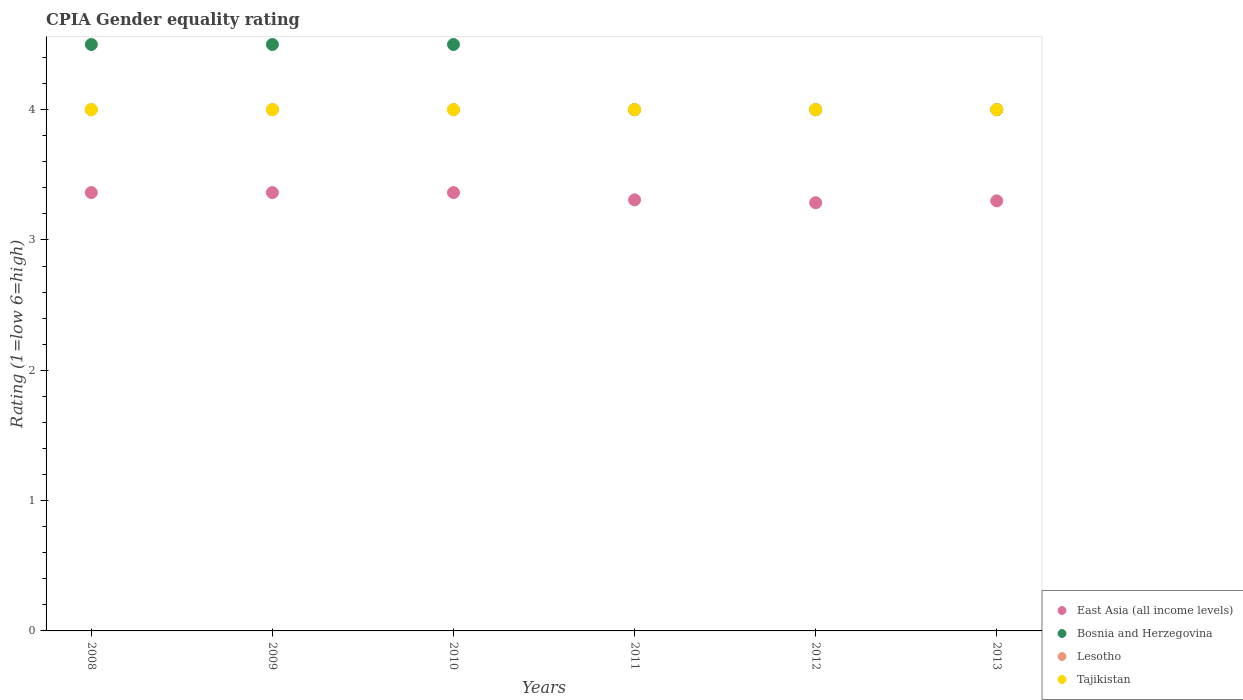How many different coloured dotlines are there?
Your response must be concise. 4. What is the CPIA rating in East Asia (all income levels) in 2010?
Offer a terse response. 3.36. Across all years, what is the maximum CPIA rating in Lesotho?
Make the answer very short. 4. Across all years, what is the minimum CPIA rating in Lesotho?
Ensure brevity in your answer.  4. What is the total CPIA rating in East Asia (all income levels) in the graph?
Give a very brief answer. 19.98. What is the difference between the CPIA rating in East Asia (all income levels) in 2009 and that in 2011?
Make the answer very short. 0.06. What is the average CPIA rating in Bosnia and Herzegovina per year?
Ensure brevity in your answer.  4.25. In the year 2008, what is the difference between the CPIA rating in East Asia (all income levels) and CPIA rating in Lesotho?
Give a very brief answer. -0.64. In how many years, is the CPIA rating in East Asia (all income levels) greater than 2.8?
Make the answer very short. 6. What is the difference between the highest and the second highest CPIA rating in Lesotho?
Your response must be concise. 0. In how many years, is the CPIA rating in East Asia (all income levels) greater than the average CPIA rating in East Asia (all income levels) taken over all years?
Ensure brevity in your answer.  3. Is the sum of the CPIA rating in Lesotho in 2009 and 2010 greater than the maximum CPIA rating in Bosnia and Herzegovina across all years?
Your answer should be very brief. Yes. Is it the case that in every year, the sum of the CPIA rating in East Asia (all income levels) and CPIA rating in Lesotho  is greater than the sum of CPIA rating in Bosnia and Herzegovina and CPIA rating in Tajikistan?
Your response must be concise. No. Is it the case that in every year, the sum of the CPIA rating in East Asia (all income levels) and CPIA rating in Lesotho  is greater than the CPIA rating in Tajikistan?
Make the answer very short. Yes. Is the CPIA rating in Lesotho strictly greater than the CPIA rating in Bosnia and Herzegovina over the years?
Make the answer very short. No. How many years are there in the graph?
Offer a very short reply. 6. What is the difference between two consecutive major ticks on the Y-axis?
Make the answer very short. 1. Are the values on the major ticks of Y-axis written in scientific E-notation?
Offer a very short reply. No. Does the graph contain any zero values?
Keep it short and to the point. No. Does the graph contain grids?
Provide a succinct answer. No. Where does the legend appear in the graph?
Provide a short and direct response. Bottom right. What is the title of the graph?
Provide a short and direct response. CPIA Gender equality rating. What is the label or title of the X-axis?
Give a very brief answer. Years. What is the Rating (1=low 6=high) of East Asia (all income levels) in 2008?
Your answer should be compact. 3.36. What is the Rating (1=low 6=high) of Lesotho in 2008?
Keep it short and to the point. 4. What is the Rating (1=low 6=high) of Tajikistan in 2008?
Your answer should be very brief. 4. What is the Rating (1=low 6=high) in East Asia (all income levels) in 2009?
Keep it short and to the point. 3.36. What is the Rating (1=low 6=high) in Lesotho in 2009?
Offer a very short reply. 4. What is the Rating (1=low 6=high) in East Asia (all income levels) in 2010?
Offer a terse response. 3.36. What is the Rating (1=low 6=high) of Lesotho in 2010?
Give a very brief answer. 4. What is the Rating (1=low 6=high) in East Asia (all income levels) in 2011?
Offer a very short reply. 3.31. What is the Rating (1=low 6=high) in Lesotho in 2011?
Offer a terse response. 4. What is the Rating (1=low 6=high) in East Asia (all income levels) in 2012?
Your response must be concise. 3.29. What is the Rating (1=low 6=high) in Tajikistan in 2012?
Give a very brief answer. 4. What is the Rating (1=low 6=high) of East Asia (all income levels) in 2013?
Ensure brevity in your answer.  3.3. What is the Rating (1=low 6=high) in Lesotho in 2013?
Your response must be concise. 4. Across all years, what is the maximum Rating (1=low 6=high) of East Asia (all income levels)?
Your response must be concise. 3.36. Across all years, what is the maximum Rating (1=low 6=high) of Tajikistan?
Ensure brevity in your answer.  4. Across all years, what is the minimum Rating (1=low 6=high) of East Asia (all income levels)?
Offer a very short reply. 3.29. Across all years, what is the minimum Rating (1=low 6=high) of Lesotho?
Your answer should be very brief. 4. Across all years, what is the minimum Rating (1=low 6=high) of Tajikistan?
Keep it short and to the point. 4. What is the total Rating (1=low 6=high) of East Asia (all income levels) in the graph?
Provide a succinct answer. 19.98. What is the total Rating (1=low 6=high) in Lesotho in the graph?
Your response must be concise. 24. What is the difference between the Rating (1=low 6=high) in East Asia (all income levels) in 2008 and that in 2009?
Offer a very short reply. 0. What is the difference between the Rating (1=low 6=high) of Lesotho in 2008 and that in 2009?
Give a very brief answer. 0. What is the difference between the Rating (1=low 6=high) of Tajikistan in 2008 and that in 2009?
Your response must be concise. 0. What is the difference between the Rating (1=low 6=high) in Bosnia and Herzegovina in 2008 and that in 2010?
Offer a terse response. 0. What is the difference between the Rating (1=low 6=high) of East Asia (all income levels) in 2008 and that in 2011?
Provide a succinct answer. 0.06. What is the difference between the Rating (1=low 6=high) in East Asia (all income levels) in 2008 and that in 2012?
Your response must be concise. 0.08. What is the difference between the Rating (1=low 6=high) in East Asia (all income levels) in 2008 and that in 2013?
Your answer should be compact. 0.06. What is the difference between the Rating (1=low 6=high) in Bosnia and Herzegovina in 2008 and that in 2013?
Ensure brevity in your answer.  0.5. What is the difference between the Rating (1=low 6=high) of East Asia (all income levels) in 2009 and that in 2010?
Ensure brevity in your answer.  0. What is the difference between the Rating (1=low 6=high) in Tajikistan in 2009 and that in 2010?
Your answer should be very brief. 0. What is the difference between the Rating (1=low 6=high) in East Asia (all income levels) in 2009 and that in 2011?
Your answer should be very brief. 0.06. What is the difference between the Rating (1=low 6=high) in Bosnia and Herzegovina in 2009 and that in 2011?
Provide a succinct answer. 0.5. What is the difference between the Rating (1=low 6=high) in Tajikistan in 2009 and that in 2011?
Your answer should be compact. 0. What is the difference between the Rating (1=low 6=high) in East Asia (all income levels) in 2009 and that in 2012?
Make the answer very short. 0.08. What is the difference between the Rating (1=low 6=high) in Lesotho in 2009 and that in 2012?
Offer a terse response. 0. What is the difference between the Rating (1=low 6=high) in East Asia (all income levels) in 2009 and that in 2013?
Keep it short and to the point. 0.06. What is the difference between the Rating (1=low 6=high) in Bosnia and Herzegovina in 2009 and that in 2013?
Ensure brevity in your answer.  0.5. What is the difference between the Rating (1=low 6=high) in Lesotho in 2009 and that in 2013?
Your answer should be compact. 0. What is the difference between the Rating (1=low 6=high) of East Asia (all income levels) in 2010 and that in 2011?
Your response must be concise. 0.06. What is the difference between the Rating (1=low 6=high) of Lesotho in 2010 and that in 2011?
Offer a terse response. 0. What is the difference between the Rating (1=low 6=high) of Tajikistan in 2010 and that in 2011?
Give a very brief answer. 0. What is the difference between the Rating (1=low 6=high) of East Asia (all income levels) in 2010 and that in 2012?
Keep it short and to the point. 0.08. What is the difference between the Rating (1=low 6=high) of Bosnia and Herzegovina in 2010 and that in 2012?
Your response must be concise. 0.5. What is the difference between the Rating (1=low 6=high) in Tajikistan in 2010 and that in 2012?
Make the answer very short. 0. What is the difference between the Rating (1=low 6=high) in East Asia (all income levels) in 2010 and that in 2013?
Keep it short and to the point. 0.06. What is the difference between the Rating (1=low 6=high) of Bosnia and Herzegovina in 2010 and that in 2013?
Provide a short and direct response. 0.5. What is the difference between the Rating (1=low 6=high) in Lesotho in 2010 and that in 2013?
Offer a very short reply. 0. What is the difference between the Rating (1=low 6=high) in Tajikistan in 2010 and that in 2013?
Your response must be concise. 0. What is the difference between the Rating (1=low 6=high) of East Asia (all income levels) in 2011 and that in 2012?
Offer a terse response. 0.02. What is the difference between the Rating (1=low 6=high) of Tajikistan in 2011 and that in 2012?
Your answer should be compact. 0. What is the difference between the Rating (1=low 6=high) in East Asia (all income levels) in 2011 and that in 2013?
Your answer should be very brief. 0.01. What is the difference between the Rating (1=low 6=high) in Bosnia and Herzegovina in 2011 and that in 2013?
Your answer should be compact. 0. What is the difference between the Rating (1=low 6=high) in Tajikistan in 2011 and that in 2013?
Keep it short and to the point. 0. What is the difference between the Rating (1=low 6=high) in East Asia (all income levels) in 2012 and that in 2013?
Offer a very short reply. -0.01. What is the difference between the Rating (1=low 6=high) in Lesotho in 2012 and that in 2013?
Your response must be concise. 0. What is the difference between the Rating (1=low 6=high) in East Asia (all income levels) in 2008 and the Rating (1=low 6=high) in Bosnia and Herzegovina in 2009?
Give a very brief answer. -1.14. What is the difference between the Rating (1=low 6=high) in East Asia (all income levels) in 2008 and the Rating (1=low 6=high) in Lesotho in 2009?
Your answer should be compact. -0.64. What is the difference between the Rating (1=low 6=high) in East Asia (all income levels) in 2008 and the Rating (1=low 6=high) in Tajikistan in 2009?
Keep it short and to the point. -0.64. What is the difference between the Rating (1=low 6=high) of Bosnia and Herzegovina in 2008 and the Rating (1=low 6=high) of Lesotho in 2009?
Make the answer very short. 0.5. What is the difference between the Rating (1=low 6=high) in Lesotho in 2008 and the Rating (1=low 6=high) in Tajikistan in 2009?
Keep it short and to the point. 0. What is the difference between the Rating (1=low 6=high) in East Asia (all income levels) in 2008 and the Rating (1=low 6=high) in Bosnia and Herzegovina in 2010?
Your response must be concise. -1.14. What is the difference between the Rating (1=low 6=high) of East Asia (all income levels) in 2008 and the Rating (1=low 6=high) of Lesotho in 2010?
Your answer should be very brief. -0.64. What is the difference between the Rating (1=low 6=high) of East Asia (all income levels) in 2008 and the Rating (1=low 6=high) of Tajikistan in 2010?
Provide a short and direct response. -0.64. What is the difference between the Rating (1=low 6=high) in Bosnia and Herzegovina in 2008 and the Rating (1=low 6=high) in Lesotho in 2010?
Offer a very short reply. 0.5. What is the difference between the Rating (1=low 6=high) of Lesotho in 2008 and the Rating (1=low 6=high) of Tajikistan in 2010?
Your answer should be very brief. 0. What is the difference between the Rating (1=low 6=high) in East Asia (all income levels) in 2008 and the Rating (1=low 6=high) in Bosnia and Herzegovina in 2011?
Ensure brevity in your answer.  -0.64. What is the difference between the Rating (1=low 6=high) of East Asia (all income levels) in 2008 and the Rating (1=low 6=high) of Lesotho in 2011?
Your response must be concise. -0.64. What is the difference between the Rating (1=low 6=high) of East Asia (all income levels) in 2008 and the Rating (1=low 6=high) of Tajikistan in 2011?
Provide a succinct answer. -0.64. What is the difference between the Rating (1=low 6=high) of Bosnia and Herzegovina in 2008 and the Rating (1=low 6=high) of Tajikistan in 2011?
Keep it short and to the point. 0.5. What is the difference between the Rating (1=low 6=high) of Lesotho in 2008 and the Rating (1=low 6=high) of Tajikistan in 2011?
Keep it short and to the point. 0. What is the difference between the Rating (1=low 6=high) in East Asia (all income levels) in 2008 and the Rating (1=low 6=high) in Bosnia and Herzegovina in 2012?
Your answer should be compact. -0.64. What is the difference between the Rating (1=low 6=high) in East Asia (all income levels) in 2008 and the Rating (1=low 6=high) in Lesotho in 2012?
Offer a very short reply. -0.64. What is the difference between the Rating (1=low 6=high) in East Asia (all income levels) in 2008 and the Rating (1=low 6=high) in Tajikistan in 2012?
Offer a very short reply. -0.64. What is the difference between the Rating (1=low 6=high) in Bosnia and Herzegovina in 2008 and the Rating (1=low 6=high) in Lesotho in 2012?
Your answer should be very brief. 0.5. What is the difference between the Rating (1=low 6=high) in Lesotho in 2008 and the Rating (1=low 6=high) in Tajikistan in 2012?
Your response must be concise. 0. What is the difference between the Rating (1=low 6=high) in East Asia (all income levels) in 2008 and the Rating (1=low 6=high) in Bosnia and Herzegovina in 2013?
Your answer should be very brief. -0.64. What is the difference between the Rating (1=low 6=high) of East Asia (all income levels) in 2008 and the Rating (1=low 6=high) of Lesotho in 2013?
Make the answer very short. -0.64. What is the difference between the Rating (1=low 6=high) in East Asia (all income levels) in 2008 and the Rating (1=low 6=high) in Tajikistan in 2013?
Ensure brevity in your answer.  -0.64. What is the difference between the Rating (1=low 6=high) of East Asia (all income levels) in 2009 and the Rating (1=low 6=high) of Bosnia and Herzegovina in 2010?
Your answer should be very brief. -1.14. What is the difference between the Rating (1=low 6=high) in East Asia (all income levels) in 2009 and the Rating (1=low 6=high) in Lesotho in 2010?
Keep it short and to the point. -0.64. What is the difference between the Rating (1=low 6=high) of East Asia (all income levels) in 2009 and the Rating (1=low 6=high) of Tajikistan in 2010?
Keep it short and to the point. -0.64. What is the difference between the Rating (1=low 6=high) in Bosnia and Herzegovina in 2009 and the Rating (1=low 6=high) in Lesotho in 2010?
Your answer should be compact. 0.5. What is the difference between the Rating (1=low 6=high) in East Asia (all income levels) in 2009 and the Rating (1=low 6=high) in Bosnia and Herzegovina in 2011?
Keep it short and to the point. -0.64. What is the difference between the Rating (1=low 6=high) of East Asia (all income levels) in 2009 and the Rating (1=low 6=high) of Lesotho in 2011?
Offer a terse response. -0.64. What is the difference between the Rating (1=low 6=high) in East Asia (all income levels) in 2009 and the Rating (1=low 6=high) in Tajikistan in 2011?
Make the answer very short. -0.64. What is the difference between the Rating (1=low 6=high) in Bosnia and Herzegovina in 2009 and the Rating (1=low 6=high) in Lesotho in 2011?
Your answer should be compact. 0.5. What is the difference between the Rating (1=low 6=high) in Lesotho in 2009 and the Rating (1=low 6=high) in Tajikistan in 2011?
Your answer should be compact. 0. What is the difference between the Rating (1=low 6=high) in East Asia (all income levels) in 2009 and the Rating (1=low 6=high) in Bosnia and Herzegovina in 2012?
Provide a succinct answer. -0.64. What is the difference between the Rating (1=low 6=high) in East Asia (all income levels) in 2009 and the Rating (1=low 6=high) in Lesotho in 2012?
Keep it short and to the point. -0.64. What is the difference between the Rating (1=low 6=high) in East Asia (all income levels) in 2009 and the Rating (1=low 6=high) in Tajikistan in 2012?
Give a very brief answer. -0.64. What is the difference between the Rating (1=low 6=high) in Bosnia and Herzegovina in 2009 and the Rating (1=low 6=high) in Lesotho in 2012?
Make the answer very short. 0.5. What is the difference between the Rating (1=low 6=high) of East Asia (all income levels) in 2009 and the Rating (1=low 6=high) of Bosnia and Herzegovina in 2013?
Keep it short and to the point. -0.64. What is the difference between the Rating (1=low 6=high) in East Asia (all income levels) in 2009 and the Rating (1=low 6=high) in Lesotho in 2013?
Make the answer very short. -0.64. What is the difference between the Rating (1=low 6=high) in East Asia (all income levels) in 2009 and the Rating (1=low 6=high) in Tajikistan in 2013?
Provide a succinct answer. -0.64. What is the difference between the Rating (1=low 6=high) of Bosnia and Herzegovina in 2009 and the Rating (1=low 6=high) of Lesotho in 2013?
Make the answer very short. 0.5. What is the difference between the Rating (1=low 6=high) in Bosnia and Herzegovina in 2009 and the Rating (1=low 6=high) in Tajikistan in 2013?
Keep it short and to the point. 0.5. What is the difference between the Rating (1=low 6=high) in Lesotho in 2009 and the Rating (1=low 6=high) in Tajikistan in 2013?
Offer a very short reply. 0. What is the difference between the Rating (1=low 6=high) of East Asia (all income levels) in 2010 and the Rating (1=low 6=high) of Bosnia and Herzegovina in 2011?
Provide a short and direct response. -0.64. What is the difference between the Rating (1=low 6=high) in East Asia (all income levels) in 2010 and the Rating (1=low 6=high) in Lesotho in 2011?
Provide a succinct answer. -0.64. What is the difference between the Rating (1=low 6=high) in East Asia (all income levels) in 2010 and the Rating (1=low 6=high) in Tajikistan in 2011?
Give a very brief answer. -0.64. What is the difference between the Rating (1=low 6=high) in Lesotho in 2010 and the Rating (1=low 6=high) in Tajikistan in 2011?
Your response must be concise. 0. What is the difference between the Rating (1=low 6=high) of East Asia (all income levels) in 2010 and the Rating (1=low 6=high) of Bosnia and Herzegovina in 2012?
Offer a very short reply. -0.64. What is the difference between the Rating (1=low 6=high) of East Asia (all income levels) in 2010 and the Rating (1=low 6=high) of Lesotho in 2012?
Your answer should be compact. -0.64. What is the difference between the Rating (1=low 6=high) in East Asia (all income levels) in 2010 and the Rating (1=low 6=high) in Tajikistan in 2012?
Your answer should be compact. -0.64. What is the difference between the Rating (1=low 6=high) of East Asia (all income levels) in 2010 and the Rating (1=low 6=high) of Bosnia and Herzegovina in 2013?
Offer a terse response. -0.64. What is the difference between the Rating (1=low 6=high) of East Asia (all income levels) in 2010 and the Rating (1=low 6=high) of Lesotho in 2013?
Provide a succinct answer. -0.64. What is the difference between the Rating (1=low 6=high) in East Asia (all income levels) in 2010 and the Rating (1=low 6=high) in Tajikistan in 2013?
Ensure brevity in your answer.  -0.64. What is the difference between the Rating (1=low 6=high) of Lesotho in 2010 and the Rating (1=low 6=high) of Tajikistan in 2013?
Provide a succinct answer. 0. What is the difference between the Rating (1=low 6=high) of East Asia (all income levels) in 2011 and the Rating (1=low 6=high) of Bosnia and Herzegovina in 2012?
Provide a succinct answer. -0.69. What is the difference between the Rating (1=low 6=high) of East Asia (all income levels) in 2011 and the Rating (1=low 6=high) of Lesotho in 2012?
Your answer should be very brief. -0.69. What is the difference between the Rating (1=low 6=high) of East Asia (all income levels) in 2011 and the Rating (1=low 6=high) of Tajikistan in 2012?
Offer a very short reply. -0.69. What is the difference between the Rating (1=low 6=high) of Bosnia and Herzegovina in 2011 and the Rating (1=low 6=high) of Lesotho in 2012?
Your answer should be compact. 0. What is the difference between the Rating (1=low 6=high) in Bosnia and Herzegovina in 2011 and the Rating (1=low 6=high) in Tajikistan in 2012?
Your response must be concise. 0. What is the difference between the Rating (1=low 6=high) of East Asia (all income levels) in 2011 and the Rating (1=low 6=high) of Bosnia and Herzegovina in 2013?
Your answer should be very brief. -0.69. What is the difference between the Rating (1=low 6=high) of East Asia (all income levels) in 2011 and the Rating (1=low 6=high) of Lesotho in 2013?
Provide a succinct answer. -0.69. What is the difference between the Rating (1=low 6=high) of East Asia (all income levels) in 2011 and the Rating (1=low 6=high) of Tajikistan in 2013?
Provide a succinct answer. -0.69. What is the difference between the Rating (1=low 6=high) of Bosnia and Herzegovina in 2011 and the Rating (1=low 6=high) of Lesotho in 2013?
Make the answer very short. 0. What is the difference between the Rating (1=low 6=high) of Lesotho in 2011 and the Rating (1=low 6=high) of Tajikistan in 2013?
Ensure brevity in your answer.  0. What is the difference between the Rating (1=low 6=high) in East Asia (all income levels) in 2012 and the Rating (1=low 6=high) in Bosnia and Herzegovina in 2013?
Provide a short and direct response. -0.71. What is the difference between the Rating (1=low 6=high) in East Asia (all income levels) in 2012 and the Rating (1=low 6=high) in Lesotho in 2013?
Offer a very short reply. -0.71. What is the difference between the Rating (1=low 6=high) in East Asia (all income levels) in 2012 and the Rating (1=low 6=high) in Tajikistan in 2013?
Keep it short and to the point. -0.71. What is the difference between the Rating (1=low 6=high) of Lesotho in 2012 and the Rating (1=low 6=high) of Tajikistan in 2013?
Offer a terse response. 0. What is the average Rating (1=low 6=high) in East Asia (all income levels) per year?
Ensure brevity in your answer.  3.33. What is the average Rating (1=low 6=high) in Bosnia and Herzegovina per year?
Give a very brief answer. 4.25. In the year 2008, what is the difference between the Rating (1=low 6=high) in East Asia (all income levels) and Rating (1=low 6=high) in Bosnia and Herzegovina?
Your answer should be very brief. -1.14. In the year 2008, what is the difference between the Rating (1=low 6=high) of East Asia (all income levels) and Rating (1=low 6=high) of Lesotho?
Provide a short and direct response. -0.64. In the year 2008, what is the difference between the Rating (1=low 6=high) of East Asia (all income levels) and Rating (1=low 6=high) of Tajikistan?
Provide a succinct answer. -0.64. In the year 2008, what is the difference between the Rating (1=low 6=high) in Lesotho and Rating (1=low 6=high) in Tajikistan?
Give a very brief answer. 0. In the year 2009, what is the difference between the Rating (1=low 6=high) of East Asia (all income levels) and Rating (1=low 6=high) of Bosnia and Herzegovina?
Offer a terse response. -1.14. In the year 2009, what is the difference between the Rating (1=low 6=high) of East Asia (all income levels) and Rating (1=low 6=high) of Lesotho?
Keep it short and to the point. -0.64. In the year 2009, what is the difference between the Rating (1=low 6=high) of East Asia (all income levels) and Rating (1=low 6=high) of Tajikistan?
Offer a terse response. -0.64. In the year 2010, what is the difference between the Rating (1=low 6=high) of East Asia (all income levels) and Rating (1=low 6=high) of Bosnia and Herzegovina?
Provide a succinct answer. -1.14. In the year 2010, what is the difference between the Rating (1=low 6=high) in East Asia (all income levels) and Rating (1=low 6=high) in Lesotho?
Provide a short and direct response. -0.64. In the year 2010, what is the difference between the Rating (1=low 6=high) in East Asia (all income levels) and Rating (1=low 6=high) in Tajikistan?
Your response must be concise. -0.64. In the year 2010, what is the difference between the Rating (1=low 6=high) in Bosnia and Herzegovina and Rating (1=low 6=high) in Lesotho?
Provide a succinct answer. 0.5. In the year 2010, what is the difference between the Rating (1=low 6=high) of Bosnia and Herzegovina and Rating (1=low 6=high) of Tajikistan?
Keep it short and to the point. 0.5. In the year 2011, what is the difference between the Rating (1=low 6=high) of East Asia (all income levels) and Rating (1=low 6=high) of Bosnia and Herzegovina?
Your answer should be very brief. -0.69. In the year 2011, what is the difference between the Rating (1=low 6=high) in East Asia (all income levels) and Rating (1=low 6=high) in Lesotho?
Give a very brief answer. -0.69. In the year 2011, what is the difference between the Rating (1=low 6=high) in East Asia (all income levels) and Rating (1=low 6=high) in Tajikistan?
Give a very brief answer. -0.69. In the year 2011, what is the difference between the Rating (1=low 6=high) in Bosnia and Herzegovina and Rating (1=low 6=high) in Lesotho?
Offer a very short reply. 0. In the year 2011, what is the difference between the Rating (1=low 6=high) in Lesotho and Rating (1=low 6=high) in Tajikistan?
Offer a very short reply. 0. In the year 2012, what is the difference between the Rating (1=low 6=high) of East Asia (all income levels) and Rating (1=low 6=high) of Bosnia and Herzegovina?
Provide a succinct answer. -0.71. In the year 2012, what is the difference between the Rating (1=low 6=high) of East Asia (all income levels) and Rating (1=low 6=high) of Lesotho?
Your answer should be very brief. -0.71. In the year 2012, what is the difference between the Rating (1=low 6=high) in East Asia (all income levels) and Rating (1=low 6=high) in Tajikistan?
Provide a succinct answer. -0.71. In the year 2013, what is the difference between the Rating (1=low 6=high) of East Asia (all income levels) and Rating (1=low 6=high) of Lesotho?
Ensure brevity in your answer.  -0.7. In the year 2013, what is the difference between the Rating (1=low 6=high) in East Asia (all income levels) and Rating (1=low 6=high) in Tajikistan?
Provide a succinct answer. -0.7. In the year 2013, what is the difference between the Rating (1=low 6=high) in Bosnia and Herzegovina and Rating (1=low 6=high) in Lesotho?
Your answer should be very brief. 0. In the year 2013, what is the difference between the Rating (1=low 6=high) of Bosnia and Herzegovina and Rating (1=low 6=high) of Tajikistan?
Your answer should be very brief. 0. What is the ratio of the Rating (1=low 6=high) of Lesotho in 2008 to that in 2009?
Keep it short and to the point. 1. What is the ratio of the Rating (1=low 6=high) of Lesotho in 2008 to that in 2010?
Offer a terse response. 1. What is the ratio of the Rating (1=low 6=high) of East Asia (all income levels) in 2008 to that in 2011?
Your response must be concise. 1.02. What is the ratio of the Rating (1=low 6=high) in Bosnia and Herzegovina in 2008 to that in 2011?
Make the answer very short. 1.12. What is the ratio of the Rating (1=low 6=high) in East Asia (all income levels) in 2008 to that in 2012?
Your answer should be compact. 1.02. What is the ratio of the Rating (1=low 6=high) in Bosnia and Herzegovina in 2008 to that in 2012?
Provide a short and direct response. 1.12. What is the ratio of the Rating (1=low 6=high) of Lesotho in 2008 to that in 2012?
Provide a succinct answer. 1. What is the ratio of the Rating (1=low 6=high) of Tajikistan in 2008 to that in 2012?
Your response must be concise. 1. What is the ratio of the Rating (1=low 6=high) in East Asia (all income levels) in 2008 to that in 2013?
Your answer should be compact. 1.02. What is the ratio of the Rating (1=low 6=high) in Bosnia and Herzegovina in 2008 to that in 2013?
Your response must be concise. 1.12. What is the ratio of the Rating (1=low 6=high) of Tajikistan in 2008 to that in 2013?
Provide a short and direct response. 1. What is the ratio of the Rating (1=low 6=high) in East Asia (all income levels) in 2009 to that in 2010?
Offer a terse response. 1. What is the ratio of the Rating (1=low 6=high) of Tajikistan in 2009 to that in 2010?
Offer a terse response. 1. What is the ratio of the Rating (1=low 6=high) in East Asia (all income levels) in 2009 to that in 2011?
Keep it short and to the point. 1.02. What is the ratio of the Rating (1=low 6=high) in Bosnia and Herzegovina in 2009 to that in 2011?
Keep it short and to the point. 1.12. What is the ratio of the Rating (1=low 6=high) in Lesotho in 2009 to that in 2011?
Provide a succinct answer. 1. What is the ratio of the Rating (1=low 6=high) in East Asia (all income levels) in 2009 to that in 2012?
Your answer should be very brief. 1.02. What is the ratio of the Rating (1=low 6=high) in Bosnia and Herzegovina in 2009 to that in 2012?
Your answer should be very brief. 1.12. What is the ratio of the Rating (1=low 6=high) of East Asia (all income levels) in 2009 to that in 2013?
Your response must be concise. 1.02. What is the ratio of the Rating (1=low 6=high) of Lesotho in 2009 to that in 2013?
Ensure brevity in your answer.  1. What is the ratio of the Rating (1=low 6=high) in Tajikistan in 2009 to that in 2013?
Your answer should be compact. 1. What is the ratio of the Rating (1=low 6=high) in East Asia (all income levels) in 2010 to that in 2011?
Provide a short and direct response. 1.02. What is the ratio of the Rating (1=low 6=high) of Lesotho in 2010 to that in 2011?
Your response must be concise. 1. What is the ratio of the Rating (1=low 6=high) of Tajikistan in 2010 to that in 2011?
Ensure brevity in your answer.  1. What is the ratio of the Rating (1=low 6=high) of East Asia (all income levels) in 2010 to that in 2012?
Offer a terse response. 1.02. What is the ratio of the Rating (1=low 6=high) of East Asia (all income levels) in 2010 to that in 2013?
Offer a terse response. 1.02. What is the ratio of the Rating (1=low 6=high) in Tajikistan in 2010 to that in 2013?
Your response must be concise. 1. What is the ratio of the Rating (1=low 6=high) in East Asia (all income levels) in 2011 to that in 2012?
Provide a short and direct response. 1.01. What is the ratio of the Rating (1=low 6=high) of Lesotho in 2011 to that in 2013?
Keep it short and to the point. 1. What is the ratio of the Rating (1=low 6=high) in Tajikistan in 2011 to that in 2013?
Ensure brevity in your answer.  1. What is the ratio of the Rating (1=low 6=high) of Lesotho in 2012 to that in 2013?
Give a very brief answer. 1. What is the ratio of the Rating (1=low 6=high) of Tajikistan in 2012 to that in 2013?
Offer a very short reply. 1. What is the difference between the highest and the second highest Rating (1=low 6=high) in Tajikistan?
Provide a succinct answer. 0. What is the difference between the highest and the lowest Rating (1=low 6=high) in East Asia (all income levels)?
Provide a short and direct response. 0.08. What is the difference between the highest and the lowest Rating (1=low 6=high) of Bosnia and Herzegovina?
Provide a succinct answer. 0.5. What is the difference between the highest and the lowest Rating (1=low 6=high) of Lesotho?
Provide a short and direct response. 0. What is the difference between the highest and the lowest Rating (1=low 6=high) in Tajikistan?
Provide a short and direct response. 0. 